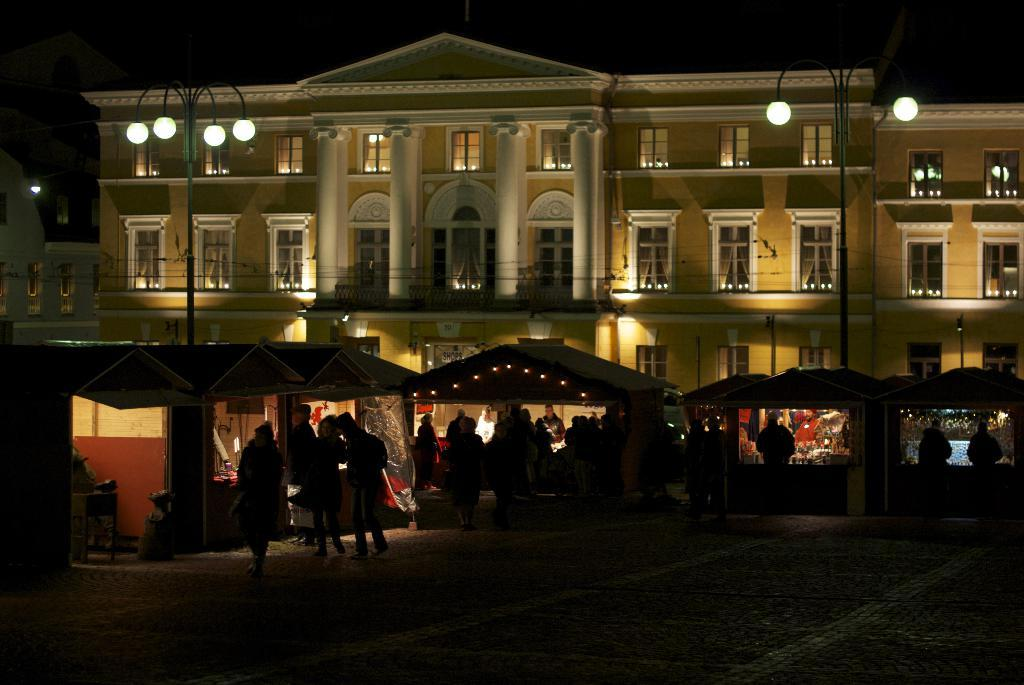What are the people in the image doing? The people in the image are standing and walking. What structures can be seen in the image? There are tents, light poles, and buildings in the image. Can you see a veil covering any of the buildings in the image? There is no veil present in the image. How does the digestion of the people in the image affect the light poles? The digestion of the people in the image does not affect the light poles, as digestion is a biological process within the body and not related to the image's content. 